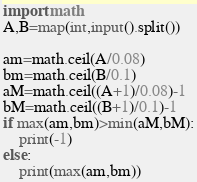Convert code to text. <code><loc_0><loc_0><loc_500><loc_500><_Python_>import math
A,B=map(int,input().split())

am=math.ceil(A/0.08)
bm=math.ceil(B/0.1)
aM=math.ceil((A+1)/0.08)-1
bM=math.ceil((B+1)/0.1)-1
if max(am,bm)>min(aM,bM):
    print(-1)
else:
    print(max(am,bm))</code> 